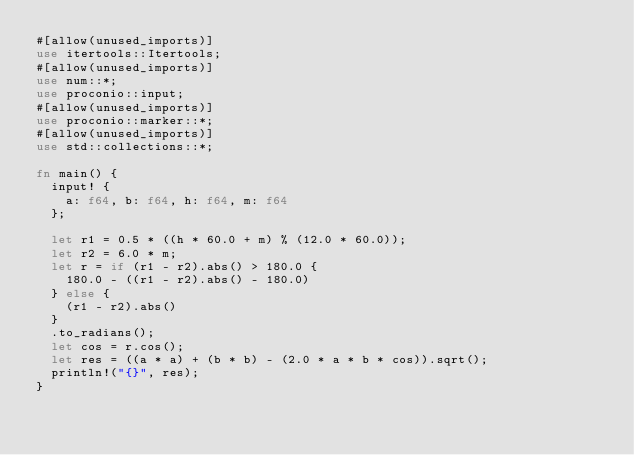<code> <loc_0><loc_0><loc_500><loc_500><_Rust_>#[allow(unused_imports)]
use itertools::Itertools;
#[allow(unused_imports)]
use num::*;
use proconio::input;
#[allow(unused_imports)]
use proconio::marker::*;
#[allow(unused_imports)]
use std::collections::*;

fn main() {
  input! {
    a: f64, b: f64, h: f64, m: f64
  };

  let r1 = 0.5 * ((h * 60.0 + m) % (12.0 * 60.0));
  let r2 = 6.0 * m;
  let r = if (r1 - r2).abs() > 180.0 {
    180.0 - ((r1 - r2).abs() - 180.0)
  } else {
    (r1 - r2).abs()
  }
  .to_radians();
  let cos = r.cos();
  let res = ((a * a) + (b * b) - (2.0 * a * b * cos)).sqrt();
  println!("{}", res);
}
</code> 